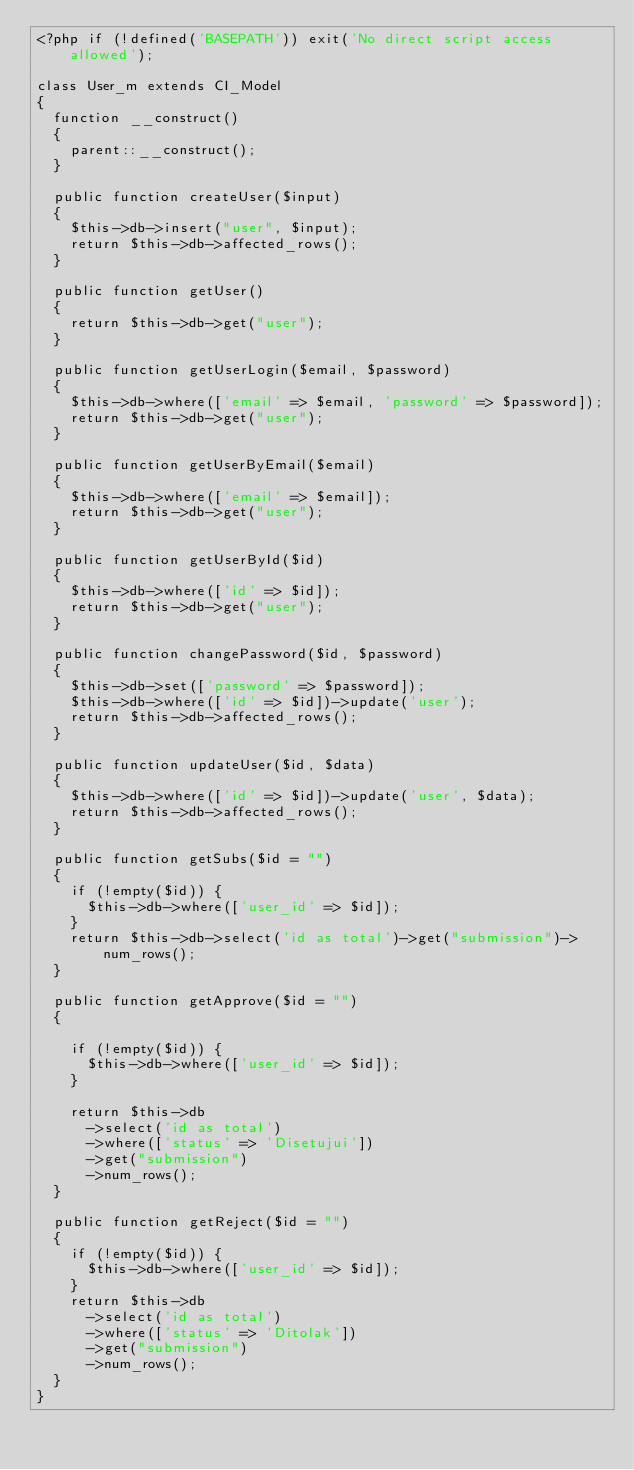Convert code to text. <code><loc_0><loc_0><loc_500><loc_500><_PHP_><?php if (!defined('BASEPATH')) exit('No direct script access allowed');

class User_m extends CI_Model
{
  function __construct()
  {
    parent::__construct();
  }

  public function createUser($input)
  {
    $this->db->insert("user", $input);
    return $this->db->affected_rows();
  }

  public function getUser()
  {
    return $this->db->get("user");
  }

  public function getUserLogin($email, $password)
  {
    $this->db->where(['email' => $email, 'password' => $password]);
    return $this->db->get("user");
  }

  public function getUserByEmail($email)
  {
    $this->db->where(['email' => $email]);
    return $this->db->get("user");
  }

  public function getUserById($id)
  {
    $this->db->where(['id' => $id]);
    return $this->db->get("user");
  }

  public function changePassword($id, $password)
  {
    $this->db->set(['password' => $password]);
    $this->db->where(['id' => $id])->update('user');
    return $this->db->affected_rows();
  }

  public function updateUser($id, $data)
  {
    $this->db->where(['id' => $id])->update('user', $data);
    return $this->db->affected_rows();
  }

  public function getSubs($id = "")
  {
    if (!empty($id)) {
      $this->db->where(['user_id' => $id]);
    }
    return $this->db->select('id as total')->get("submission")->num_rows();
  }

  public function getApprove($id = "")
  {

    if (!empty($id)) {
      $this->db->where(['user_id' => $id]);
    }

    return $this->db
      ->select('id as total')
      ->where(['status' => 'Disetujui'])
      ->get("submission")
      ->num_rows();
  }

  public function getReject($id = "")
  {
    if (!empty($id)) {
      $this->db->where(['user_id' => $id]);
    }
    return $this->db
      ->select('id as total')
      ->where(['status' => 'Ditolak'])
      ->get("submission")
      ->num_rows();
  }
}
</code> 